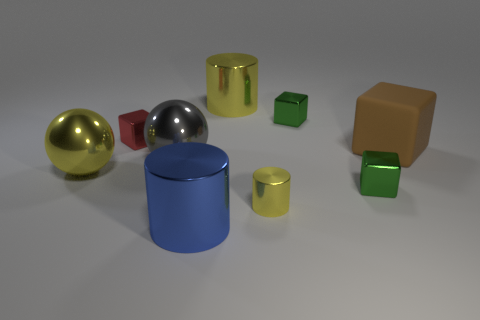Subtract all gray blocks. Subtract all red cylinders. How many blocks are left? 4 Add 1 yellow cubes. How many objects exist? 10 Subtract all balls. How many objects are left? 7 Subtract all large brown cubes. Subtract all matte cubes. How many objects are left? 7 Add 7 yellow objects. How many yellow objects are left? 10 Add 4 large cyan objects. How many large cyan objects exist? 4 Subtract 1 yellow cylinders. How many objects are left? 8 